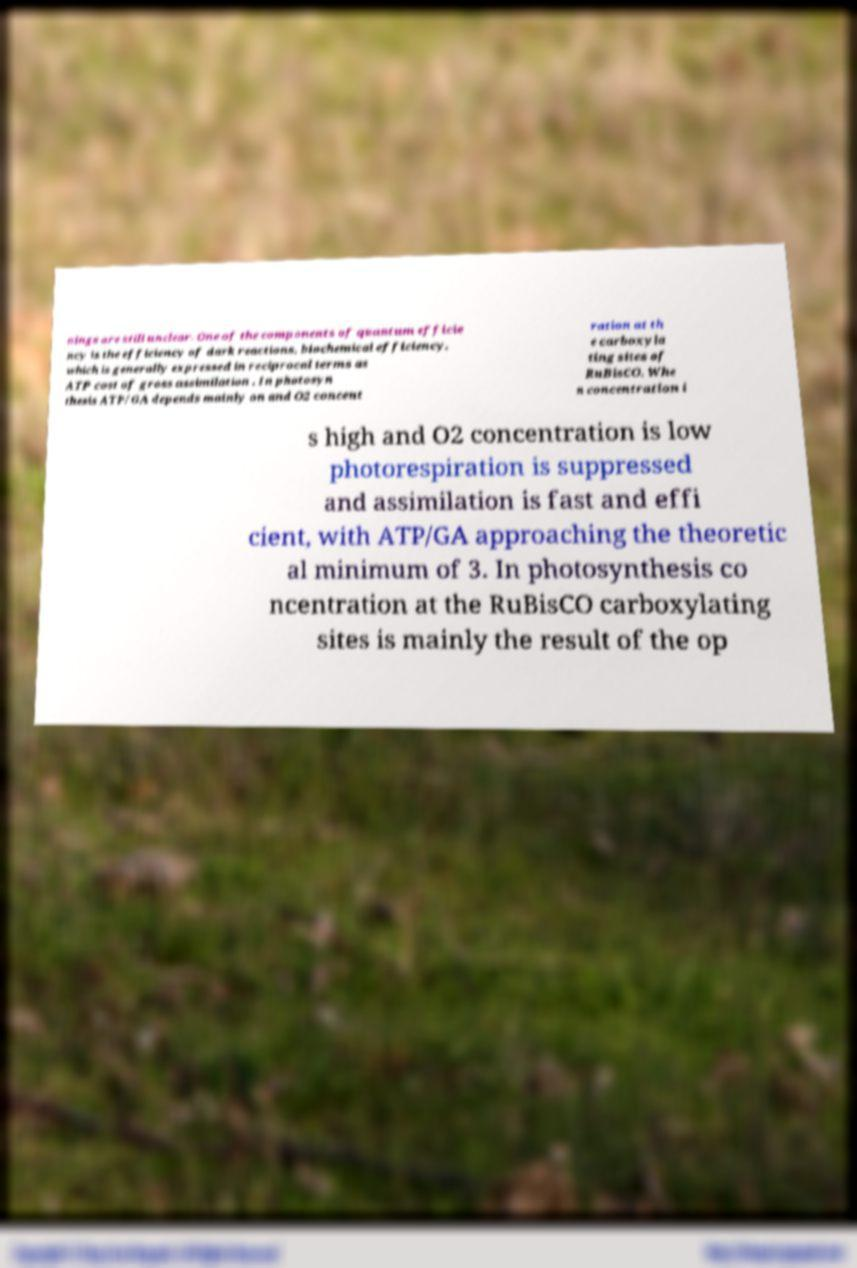Could you assist in decoding the text presented in this image and type it out clearly? nings are still unclear. One of the components of quantum efficie ncy is the efficiency of dark reactions, biochemical efficiency, which is generally expressed in reciprocal terms as ATP cost of gross assimilation . In photosyn thesis ATP/GA depends mainly on and O2 concent ration at th e carboxyla ting sites of RuBisCO. Whe n concentration i s high and O2 concentration is low photorespiration is suppressed and assimilation is fast and effi cient, with ATP/GA approaching the theoretic al minimum of 3. In photosynthesis co ncentration at the RuBisCO carboxylating sites is mainly the result of the op 